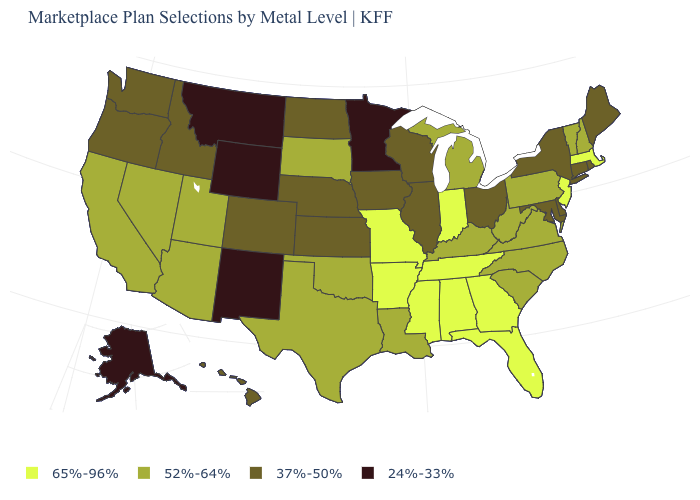Name the states that have a value in the range 37%-50%?
Quick response, please. Colorado, Connecticut, Delaware, Hawaii, Idaho, Illinois, Iowa, Kansas, Maine, Maryland, Nebraska, New York, North Dakota, Ohio, Oregon, Rhode Island, Washington, Wisconsin. What is the value of Arizona?
Short answer required. 52%-64%. What is the value of Ohio?
Give a very brief answer. 37%-50%. What is the value of South Carolina?
Give a very brief answer. 52%-64%. Which states hav the highest value in the Northeast?
Quick response, please. Massachusetts, New Jersey. Does the map have missing data?
Keep it brief. No. What is the value of Wisconsin?
Concise answer only. 37%-50%. Among the states that border Tennessee , which have the lowest value?
Give a very brief answer. Kentucky, North Carolina, Virginia. What is the lowest value in the Northeast?
Be succinct. 37%-50%. What is the value of Texas?
Keep it brief. 52%-64%. What is the highest value in the USA?
Answer briefly. 65%-96%. Does the first symbol in the legend represent the smallest category?
Short answer required. No. Name the states that have a value in the range 65%-96%?
Concise answer only. Alabama, Arkansas, Florida, Georgia, Indiana, Massachusetts, Mississippi, Missouri, New Jersey, Tennessee. What is the lowest value in states that border Texas?
Keep it brief. 24%-33%. Is the legend a continuous bar?
Concise answer only. No. 